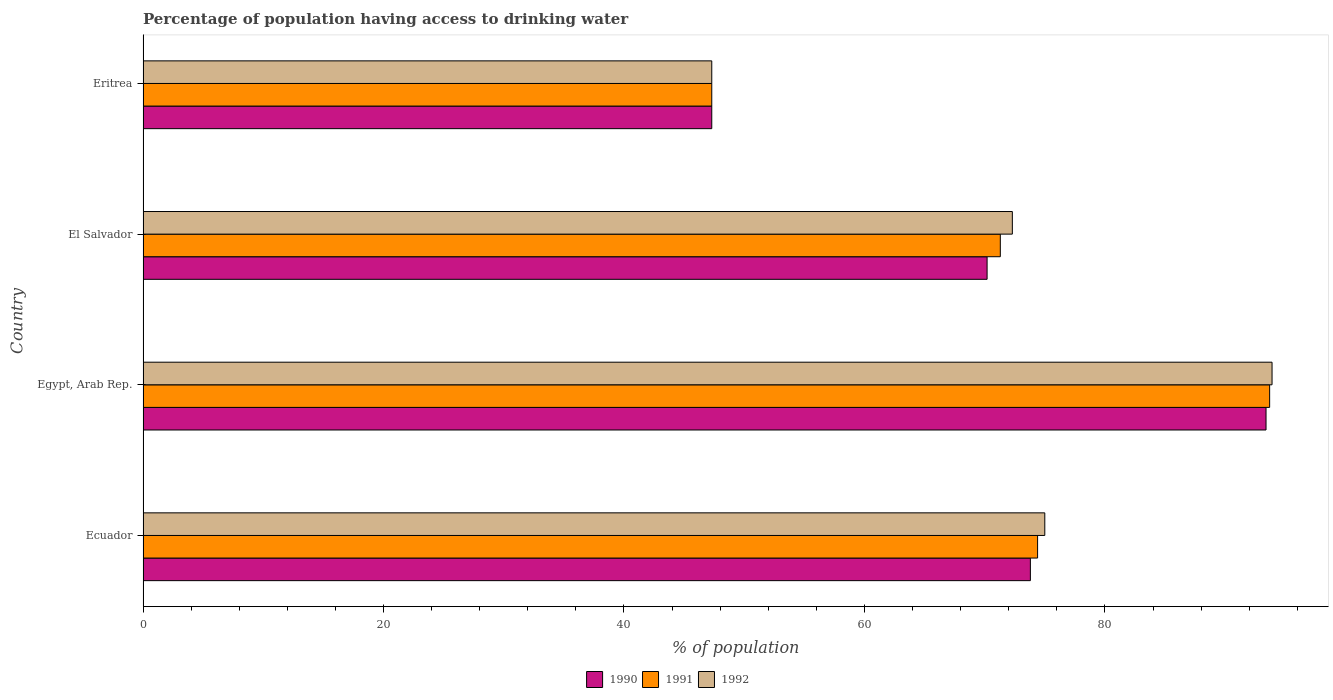How many groups of bars are there?
Keep it short and to the point. 4. Are the number of bars on each tick of the Y-axis equal?
Make the answer very short. Yes. What is the label of the 1st group of bars from the top?
Your answer should be compact. Eritrea. What is the percentage of population having access to drinking water in 1991 in El Salvador?
Give a very brief answer. 71.3. Across all countries, what is the maximum percentage of population having access to drinking water in 1992?
Give a very brief answer. 93.9. Across all countries, what is the minimum percentage of population having access to drinking water in 1990?
Provide a short and direct response. 47.3. In which country was the percentage of population having access to drinking water in 1990 maximum?
Offer a very short reply. Egypt, Arab Rep. In which country was the percentage of population having access to drinking water in 1992 minimum?
Provide a succinct answer. Eritrea. What is the total percentage of population having access to drinking water in 1992 in the graph?
Provide a short and direct response. 288.5. What is the difference between the percentage of population having access to drinking water in 1991 in Ecuador and that in El Salvador?
Offer a terse response. 3.1. What is the difference between the percentage of population having access to drinking water in 1991 in El Salvador and the percentage of population having access to drinking water in 1990 in Eritrea?
Your answer should be very brief. 24. What is the average percentage of population having access to drinking water in 1991 per country?
Keep it short and to the point. 71.68. What is the difference between the percentage of population having access to drinking water in 1990 and percentage of population having access to drinking water in 1991 in Ecuador?
Your answer should be very brief. -0.6. In how many countries, is the percentage of population having access to drinking water in 1992 greater than 36 %?
Offer a very short reply. 4. What is the ratio of the percentage of population having access to drinking water in 1992 in Egypt, Arab Rep. to that in El Salvador?
Your response must be concise. 1.3. What is the difference between the highest and the second highest percentage of population having access to drinking water in 1992?
Your answer should be very brief. 18.9. What is the difference between the highest and the lowest percentage of population having access to drinking water in 1990?
Offer a terse response. 46.1. In how many countries, is the percentage of population having access to drinking water in 1990 greater than the average percentage of population having access to drinking water in 1990 taken over all countries?
Provide a succinct answer. 2. Is the sum of the percentage of population having access to drinking water in 1991 in Ecuador and Eritrea greater than the maximum percentage of population having access to drinking water in 1990 across all countries?
Keep it short and to the point. Yes. What does the 2nd bar from the bottom in Eritrea represents?
Make the answer very short. 1991. Is it the case that in every country, the sum of the percentage of population having access to drinking water in 1992 and percentage of population having access to drinking water in 1991 is greater than the percentage of population having access to drinking water in 1990?
Your answer should be very brief. Yes. What is the difference between two consecutive major ticks on the X-axis?
Offer a terse response. 20. Does the graph contain any zero values?
Your answer should be compact. No. How are the legend labels stacked?
Your answer should be very brief. Horizontal. What is the title of the graph?
Provide a short and direct response. Percentage of population having access to drinking water. Does "2011" appear as one of the legend labels in the graph?
Give a very brief answer. No. What is the label or title of the X-axis?
Ensure brevity in your answer.  % of population. What is the % of population of 1990 in Ecuador?
Provide a succinct answer. 73.8. What is the % of population of 1991 in Ecuador?
Offer a very short reply. 74.4. What is the % of population of 1992 in Ecuador?
Offer a very short reply. 75. What is the % of population in 1990 in Egypt, Arab Rep.?
Your answer should be compact. 93.4. What is the % of population of 1991 in Egypt, Arab Rep.?
Provide a short and direct response. 93.7. What is the % of population of 1992 in Egypt, Arab Rep.?
Offer a very short reply. 93.9. What is the % of population of 1990 in El Salvador?
Your response must be concise. 70.2. What is the % of population of 1991 in El Salvador?
Keep it short and to the point. 71.3. What is the % of population of 1992 in El Salvador?
Provide a succinct answer. 72.3. What is the % of population in 1990 in Eritrea?
Your answer should be very brief. 47.3. What is the % of population in 1991 in Eritrea?
Your response must be concise. 47.3. What is the % of population in 1992 in Eritrea?
Keep it short and to the point. 47.3. Across all countries, what is the maximum % of population of 1990?
Ensure brevity in your answer.  93.4. Across all countries, what is the maximum % of population in 1991?
Provide a succinct answer. 93.7. Across all countries, what is the maximum % of population in 1992?
Keep it short and to the point. 93.9. Across all countries, what is the minimum % of population of 1990?
Provide a succinct answer. 47.3. Across all countries, what is the minimum % of population of 1991?
Your answer should be compact. 47.3. Across all countries, what is the minimum % of population of 1992?
Keep it short and to the point. 47.3. What is the total % of population of 1990 in the graph?
Your answer should be very brief. 284.7. What is the total % of population in 1991 in the graph?
Make the answer very short. 286.7. What is the total % of population of 1992 in the graph?
Offer a very short reply. 288.5. What is the difference between the % of population of 1990 in Ecuador and that in Egypt, Arab Rep.?
Provide a short and direct response. -19.6. What is the difference between the % of population of 1991 in Ecuador and that in Egypt, Arab Rep.?
Your answer should be very brief. -19.3. What is the difference between the % of population in 1992 in Ecuador and that in Egypt, Arab Rep.?
Offer a very short reply. -18.9. What is the difference between the % of population in 1992 in Ecuador and that in El Salvador?
Offer a terse response. 2.7. What is the difference between the % of population of 1991 in Ecuador and that in Eritrea?
Ensure brevity in your answer.  27.1. What is the difference between the % of population in 1992 in Ecuador and that in Eritrea?
Offer a terse response. 27.7. What is the difference between the % of population of 1990 in Egypt, Arab Rep. and that in El Salvador?
Provide a succinct answer. 23.2. What is the difference between the % of population of 1991 in Egypt, Arab Rep. and that in El Salvador?
Give a very brief answer. 22.4. What is the difference between the % of population in 1992 in Egypt, Arab Rep. and that in El Salvador?
Keep it short and to the point. 21.6. What is the difference between the % of population in 1990 in Egypt, Arab Rep. and that in Eritrea?
Provide a short and direct response. 46.1. What is the difference between the % of population of 1991 in Egypt, Arab Rep. and that in Eritrea?
Offer a terse response. 46.4. What is the difference between the % of population of 1992 in Egypt, Arab Rep. and that in Eritrea?
Provide a short and direct response. 46.6. What is the difference between the % of population of 1990 in El Salvador and that in Eritrea?
Your answer should be compact. 22.9. What is the difference between the % of population of 1991 in El Salvador and that in Eritrea?
Offer a terse response. 24. What is the difference between the % of population in 1990 in Ecuador and the % of population in 1991 in Egypt, Arab Rep.?
Your response must be concise. -19.9. What is the difference between the % of population of 1990 in Ecuador and the % of population of 1992 in Egypt, Arab Rep.?
Provide a short and direct response. -20.1. What is the difference between the % of population of 1991 in Ecuador and the % of population of 1992 in Egypt, Arab Rep.?
Keep it short and to the point. -19.5. What is the difference between the % of population in 1990 in Ecuador and the % of population in 1991 in El Salvador?
Provide a succinct answer. 2.5. What is the difference between the % of population of 1990 in Ecuador and the % of population of 1992 in El Salvador?
Your response must be concise. 1.5. What is the difference between the % of population in 1990 in Ecuador and the % of population in 1992 in Eritrea?
Offer a very short reply. 26.5. What is the difference between the % of population of 1991 in Ecuador and the % of population of 1992 in Eritrea?
Your response must be concise. 27.1. What is the difference between the % of population in 1990 in Egypt, Arab Rep. and the % of population in 1991 in El Salvador?
Your answer should be very brief. 22.1. What is the difference between the % of population in 1990 in Egypt, Arab Rep. and the % of population in 1992 in El Salvador?
Your response must be concise. 21.1. What is the difference between the % of population of 1991 in Egypt, Arab Rep. and the % of population of 1992 in El Salvador?
Offer a terse response. 21.4. What is the difference between the % of population in 1990 in Egypt, Arab Rep. and the % of population in 1991 in Eritrea?
Offer a terse response. 46.1. What is the difference between the % of population in 1990 in Egypt, Arab Rep. and the % of population in 1992 in Eritrea?
Offer a very short reply. 46.1. What is the difference between the % of population in 1991 in Egypt, Arab Rep. and the % of population in 1992 in Eritrea?
Keep it short and to the point. 46.4. What is the difference between the % of population of 1990 in El Salvador and the % of population of 1991 in Eritrea?
Make the answer very short. 22.9. What is the difference between the % of population in 1990 in El Salvador and the % of population in 1992 in Eritrea?
Your answer should be very brief. 22.9. What is the difference between the % of population of 1991 in El Salvador and the % of population of 1992 in Eritrea?
Keep it short and to the point. 24. What is the average % of population in 1990 per country?
Your answer should be compact. 71.17. What is the average % of population in 1991 per country?
Provide a short and direct response. 71.67. What is the average % of population in 1992 per country?
Offer a terse response. 72.12. What is the difference between the % of population of 1990 and % of population of 1991 in Ecuador?
Provide a succinct answer. -0.6. What is the difference between the % of population of 1991 and % of population of 1992 in Ecuador?
Offer a terse response. -0.6. What is the difference between the % of population of 1990 and % of population of 1991 in Egypt, Arab Rep.?
Provide a short and direct response. -0.3. What is the difference between the % of population of 1990 and % of population of 1992 in Egypt, Arab Rep.?
Give a very brief answer. -0.5. What is the difference between the % of population in 1991 and % of population in 1992 in El Salvador?
Your answer should be very brief. -1. What is the difference between the % of population of 1990 and % of population of 1991 in Eritrea?
Provide a short and direct response. 0. What is the difference between the % of population in 1990 and % of population in 1992 in Eritrea?
Keep it short and to the point. 0. What is the ratio of the % of population of 1990 in Ecuador to that in Egypt, Arab Rep.?
Provide a succinct answer. 0.79. What is the ratio of the % of population of 1991 in Ecuador to that in Egypt, Arab Rep.?
Offer a very short reply. 0.79. What is the ratio of the % of population in 1992 in Ecuador to that in Egypt, Arab Rep.?
Give a very brief answer. 0.8. What is the ratio of the % of population in 1990 in Ecuador to that in El Salvador?
Your response must be concise. 1.05. What is the ratio of the % of population of 1991 in Ecuador to that in El Salvador?
Ensure brevity in your answer.  1.04. What is the ratio of the % of population of 1992 in Ecuador to that in El Salvador?
Your answer should be very brief. 1.04. What is the ratio of the % of population of 1990 in Ecuador to that in Eritrea?
Give a very brief answer. 1.56. What is the ratio of the % of population of 1991 in Ecuador to that in Eritrea?
Make the answer very short. 1.57. What is the ratio of the % of population in 1992 in Ecuador to that in Eritrea?
Provide a short and direct response. 1.59. What is the ratio of the % of population of 1990 in Egypt, Arab Rep. to that in El Salvador?
Provide a short and direct response. 1.33. What is the ratio of the % of population of 1991 in Egypt, Arab Rep. to that in El Salvador?
Your answer should be very brief. 1.31. What is the ratio of the % of population of 1992 in Egypt, Arab Rep. to that in El Salvador?
Your answer should be very brief. 1.3. What is the ratio of the % of population of 1990 in Egypt, Arab Rep. to that in Eritrea?
Provide a short and direct response. 1.97. What is the ratio of the % of population in 1991 in Egypt, Arab Rep. to that in Eritrea?
Your response must be concise. 1.98. What is the ratio of the % of population in 1992 in Egypt, Arab Rep. to that in Eritrea?
Give a very brief answer. 1.99. What is the ratio of the % of population in 1990 in El Salvador to that in Eritrea?
Make the answer very short. 1.48. What is the ratio of the % of population in 1991 in El Salvador to that in Eritrea?
Offer a very short reply. 1.51. What is the ratio of the % of population of 1992 in El Salvador to that in Eritrea?
Provide a short and direct response. 1.53. What is the difference between the highest and the second highest % of population of 1990?
Offer a very short reply. 19.6. What is the difference between the highest and the second highest % of population in 1991?
Give a very brief answer. 19.3. What is the difference between the highest and the lowest % of population in 1990?
Offer a terse response. 46.1. What is the difference between the highest and the lowest % of population in 1991?
Ensure brevity in your answer.  46.4. What is the difference between the highest and the lowest % of population of 1992?
Offer a terse response. 46.6. 